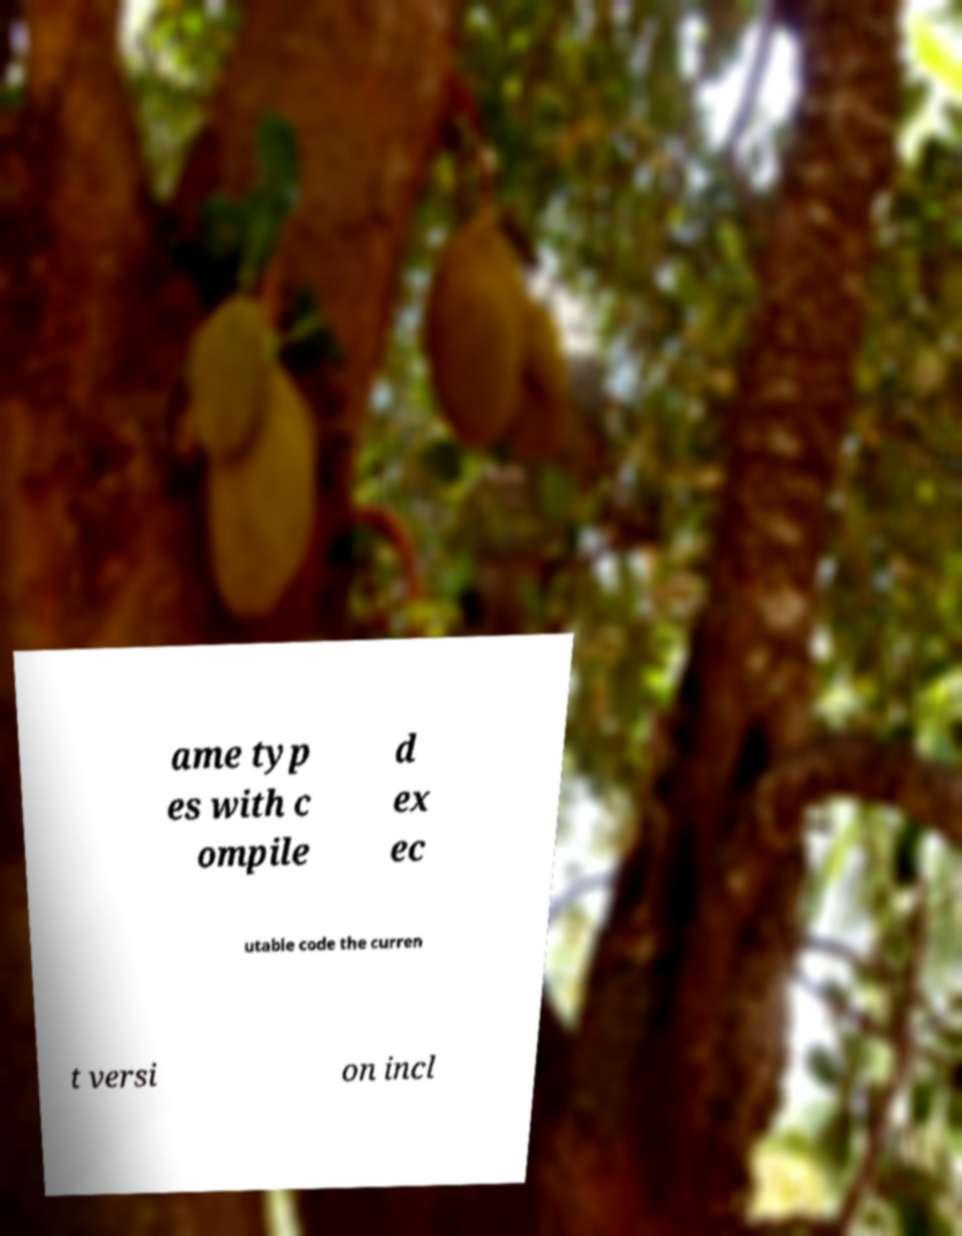What messages or text are displayed in this image? I need them in a readable, typed format. ame typ es with c ompile d ex ec utable code the curren t versi on incl 